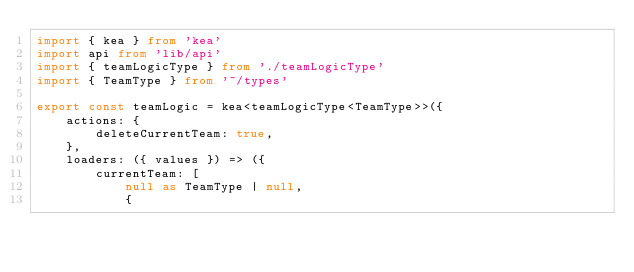<code> <loc_0><loc_0><loc_500><loc_500><_TypeScript_>import { kea } from 'kea'
import api from 'lib/api'
import { teamLogicType } from './teamLogicType'
import { TeamType } from '~/types'

export const teamLogic = kea<teamLogicType<TeamType>>({
    actions: {
        deleteCurrentTeam: true,
    },
    loaders: ({ values }) => ({
        currentTeam: [
            null as TeamType | null,
            {</code> 